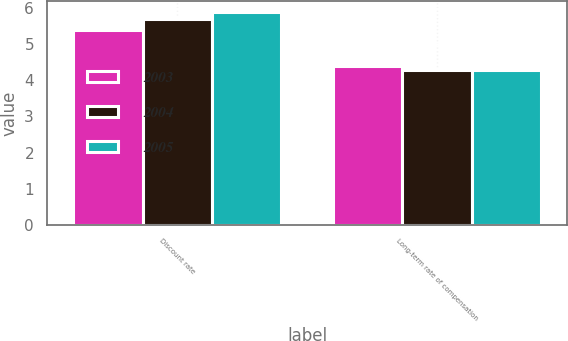Convert chart. <chart><loc_0><loc_0><loc_500><loc_500><stacked_bar_chart><ecel><fcel>Discount rate<fcel>Long-term rate of compensation<nl><fcel>2003<fcel>5.4<fcel>4.4<nl><fcel>2004<fcel>5.7<fcel>4.3<nl><fcel>2005<fcel>5.9<fcel>4.3<nl></chart> 